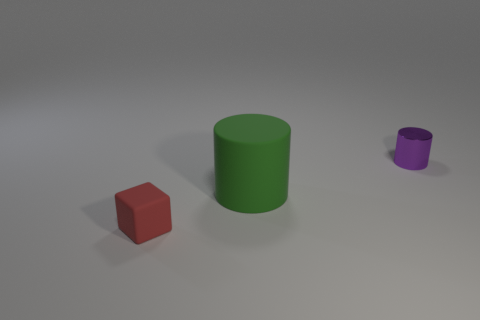Add 3 large red rubber things. How many objects exist? 6 Subtract all rubber cylinders. Subtract all big gray spheres. How many objects are left? 2 Add 3 purple shiny cylinders. How many purple shiny cylinders are left? 4 Add 3 small purple cylinders. How many small purple cylinders exist? 4 Subtract all purple cylinders. How many cylinders are left? 1 Subtract 0 cyan blocks. How many objects are left? 3 Subtract all cylinders. How many objects are left? 1 Subtract 1 blocks. How many blocks are left? 0 Subtract all blue cubes. Subtract all yellow cylinders. How many cubes are left? 1 Subtract all gray cylinders. How many purple cubes are left? 0 